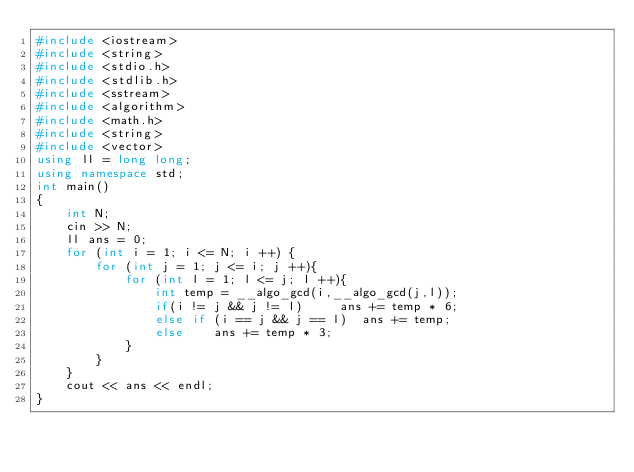<code> <loc_0><loc_0><loc_500><loc_500><_C++_>#include <iostream>
#include <string>
#include <stdio.h>
#include <stdlib.h>
#include <sstream>
#include <algorithm>
#include <math.h>
#include <string>
#include <vector>
using ll = long long;
using namespace std;
int main()
{
    int N;
    cin >> N;
    ll ans = 0;
    for (int i = 1; i <= N; i ++) {
        for (int j = 1; j <= i; j ++){
            for (int l = 1; l <= j; l ++){
                int temp = __algo_gcd(i,__algo_gcd(j,l));
                if(i != j && j != l)     ans += temp * 6;
                else if (i == j && j == l)  ans += temp;
                else    ans += temp * 3;
            }
        }
    }
    cout << ans << endl;
}
    
</code> 